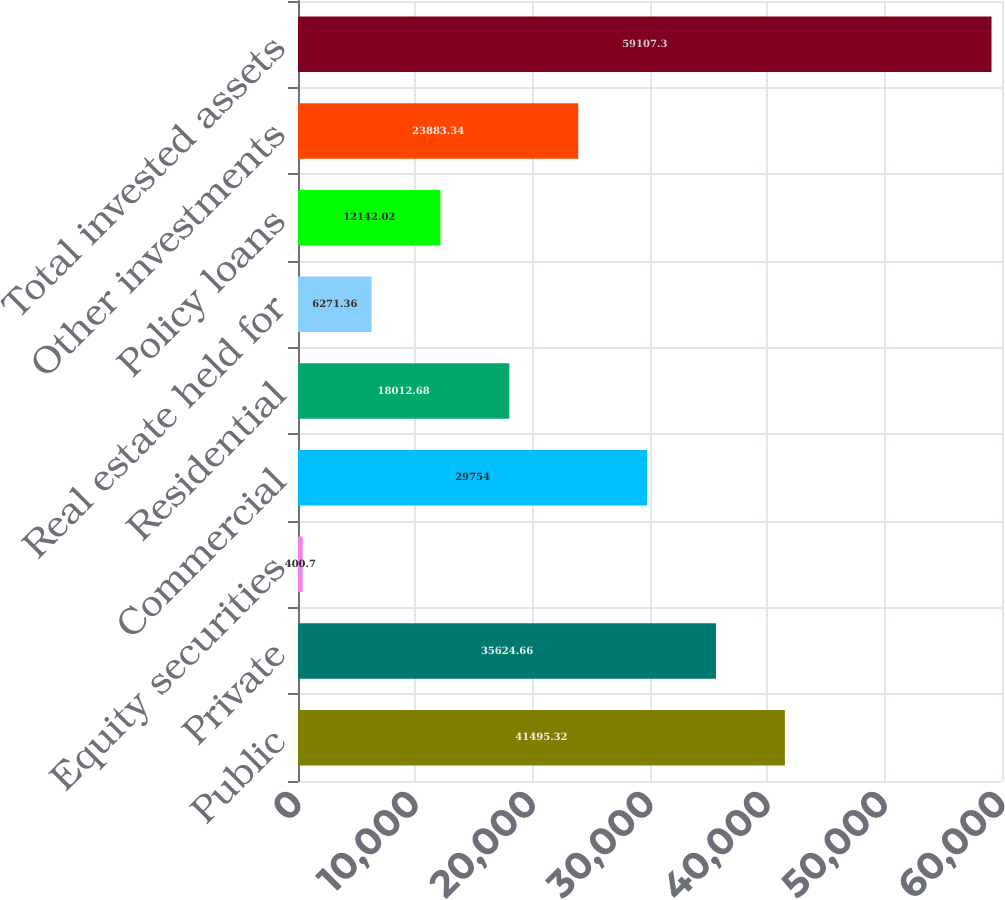<chart> <loc_0><loc_0><loc_500><loc_500><bar_chart><fcel>Public<fcel>Private<fcel>Equity securities<fcel>Commercial<fcel>Residential<fcel>Real estate held for<fcel>Policy loans<fcel>Other investments<fcel>Total invested assets<nl><fcel>41495.3<fcel>35624.7<fcel>400.7<fcel>29754<fcel>18012.7<fcel>6271.36<fcel>12142<fcel>23883.3<fcel>59107.3<nl></chart> 